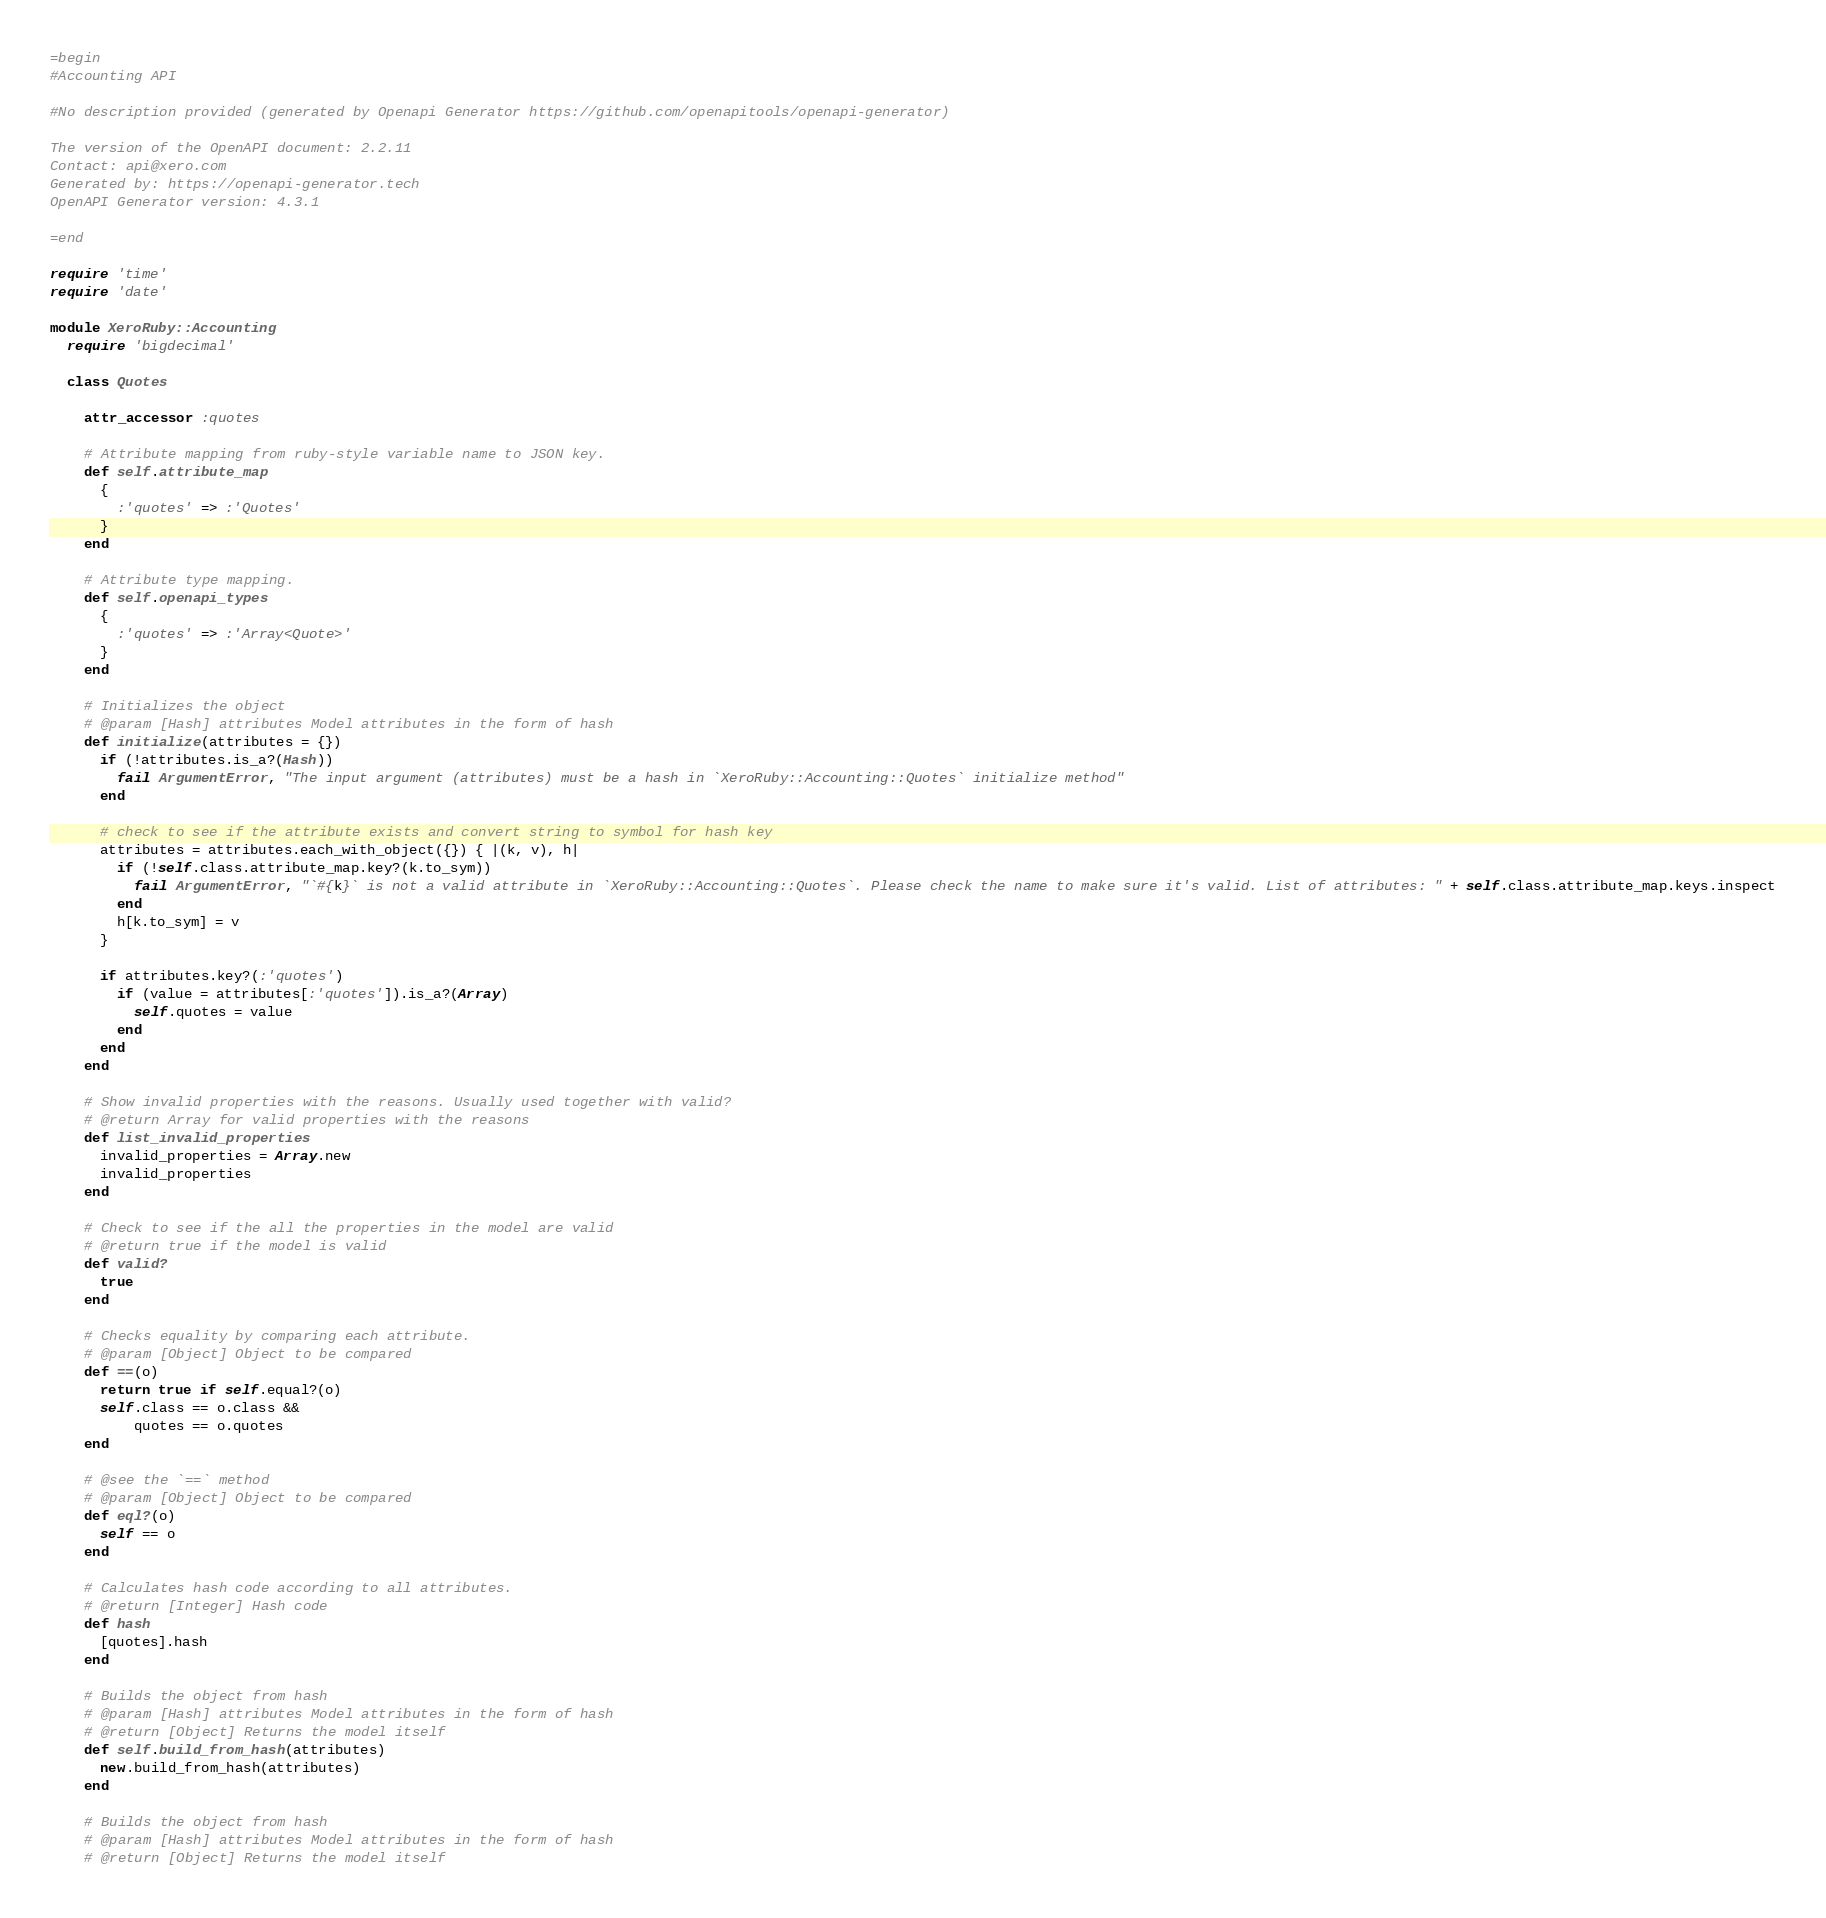Convert code to text. <code><loc_0><loc_0><loc_500><loc_500><_Ruby_>=begin
#Accounting API

#No description provided (generated by Openapi Generator https://github.com/openapitools/openapi-generator)

The version of the OpenAPI document: 2.2.11
Contact: api@xero.com
Generated by: https://openapi-generator.tech
OpenAPI Generator version: 4.3.1

=end

require 'time'
require 'date'

module XeroRuby::Accounting
  require 'bigdecimal'

  class Quotes

    attr_accessor :quotes
    
    # Attribute mapping from ruby-style variable name to JSON key.
    def self.attribute_map
      {
        :'quotes' => :'Quotes'
      }
    end

    # Attribute type mapping.
    def self.openapi_types
      {
        :'quotes' => :'Array<Quote>'
      }
    end

    # Initializes the object
    # @param [Hash] attributes Model attributes in the form of hash
    def initialize(attributes = {})
      if (!attributes.is_a?(Hash))
        fail ArgumentError, "The input argument (attributes) must be a hash in `XeroRuby::Accounting::Quotes` initialize method"
      end

      # check to see if the attribute exists and convert string to symbol for hash key
      attributes = attributes.each_with_object({}) { |(k, v), h|
        if (!self.class.attribute_map.key?(k.to_sym))
          fail ArgumentError, "`#{k}` is not a valid attribute in `XeroRuby::Accounting::Quotes`. Please check the name to make sure it's valid. List of attributes: " + self.class.attribute_map.keys.inspect
        end
        h[k.to_sym] = v
      }

      if attributes.key?(:'quotes')
        if (value = attributes[:'quotes']).is_a?(Array)
          self.quotes = value
        end
      end
    end

    # Show invalid properties with the reasons. Usually used together with valid?
    # @return Array for valid properties with the reasons
    def list_invalid_properties
      invalid_properties = Array.new
      invalid_properties
    end

    # Check to see if the all the properties in the model are valid
    # @return true if the model is valid
    def valid?
      true
    end

    # Checks equality by comparing each attribute.
    # @param [Object] Object to be compared
    def ==(o)
      return true if self.equal?(o)
      self.class == o.class &&
          quotes == o.quotes
    end

    # @see the `==` method
    # @param [Object] Object to be compared
    def eql?(o)
      self == o
    end

    # Calculates hash code according to all attributes.
    # @return [Integer] Hash code
    def hash
      [quotes].hash
    end

    # Builds the object from hash
    # @param [Hash] attributes Model attributes in the form of hash
    # @return [Object] Returns the model itself
    def self.build_from_hash(attributes)
      new.build_from_hash(attributes)
    end

    # Builds the object from hash
    # @param [Hash] attributes Model attributes in the form of hash
    # @return [Object] Returns the model itself</code> 